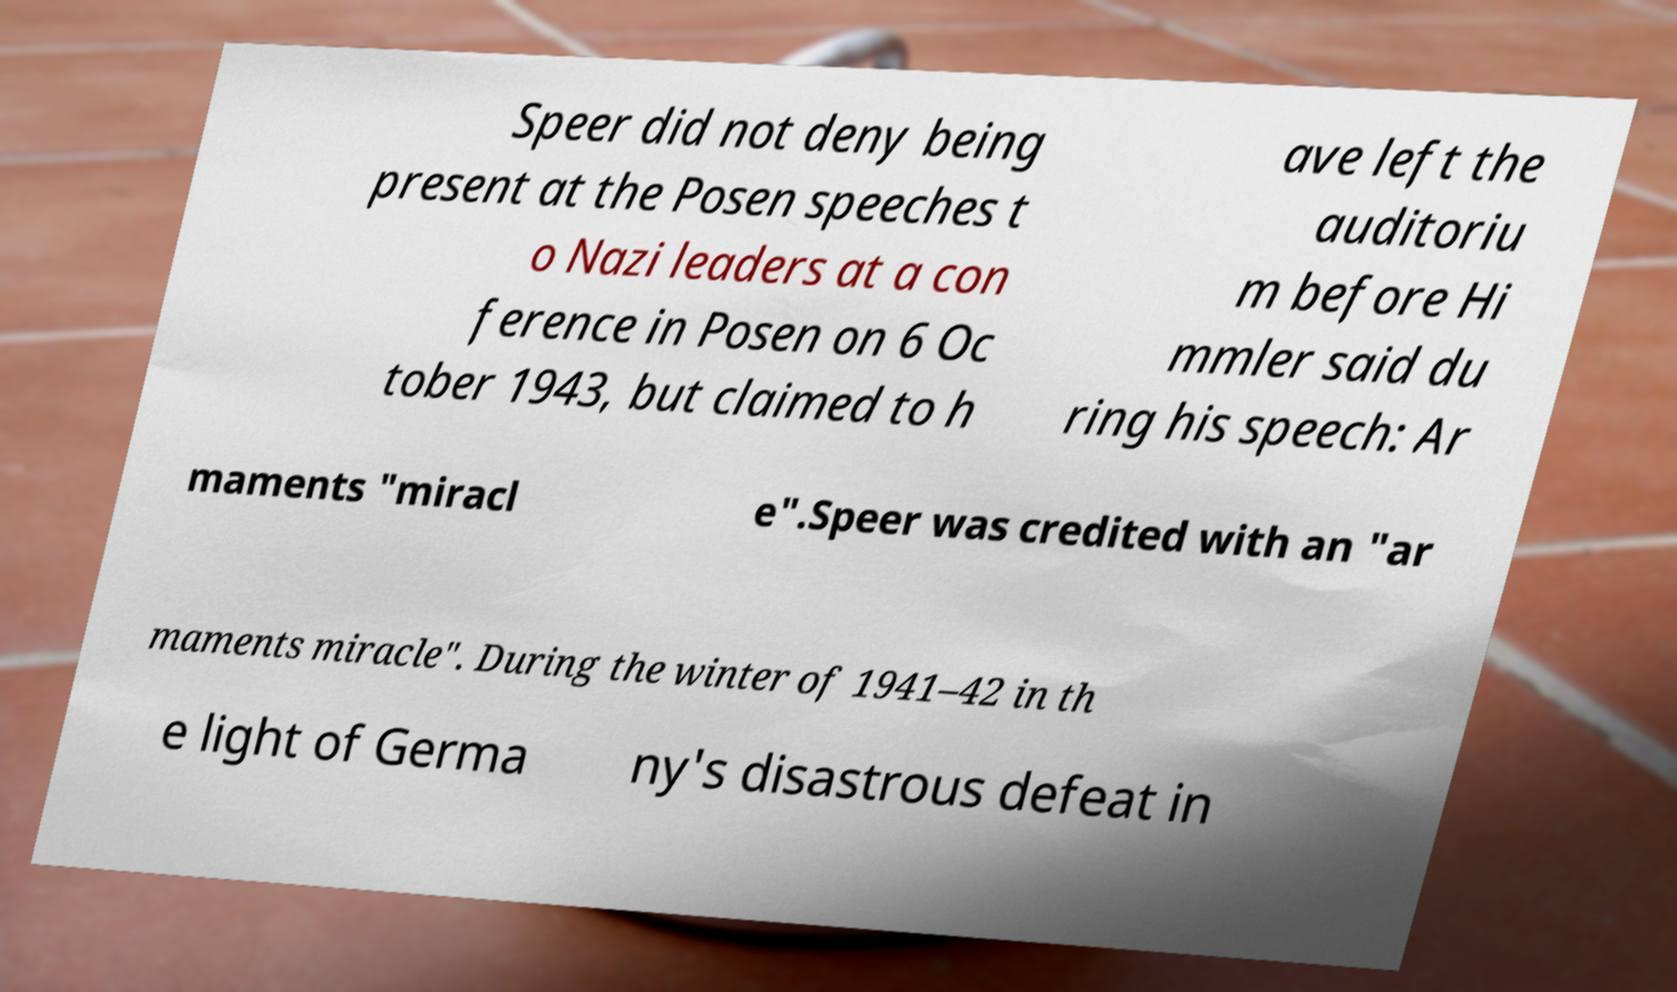Could you extract and type out the text from this image? Speer did not deny being present at the Posen speeches t o Nazi leaders at a con ference in Posen on 6 Oc tober 1943, but claimed to h ave left the auditoriu m before Hi mmler said du ring his speech: Ar maments "miracl e".Speer was credited with an "ar maments miracle". During the winter of 1941–42 in th e light of Germa ny's disastrous defeat in 